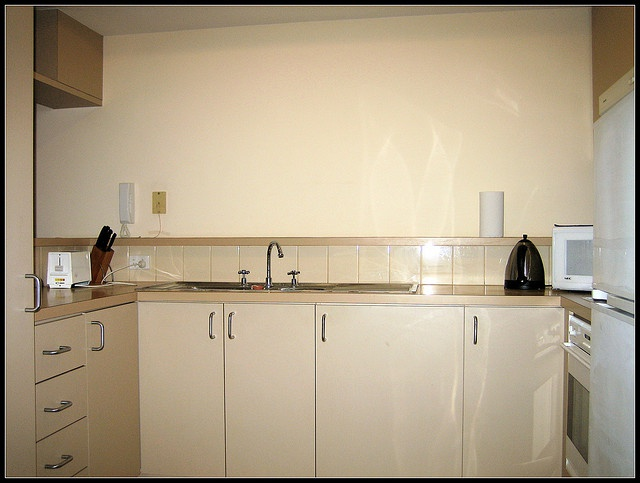Describe the objects in this image and their specific colors. I can see refrigerator in black, darkgray, lightgray, and gray tones, sink in black, gray, and tan tones, oven in black, gray, and darkgray tones, microwave in black, lightgray, darkgray, and gray tones, and knife in black, darkgreen, and gray tones in this image. 